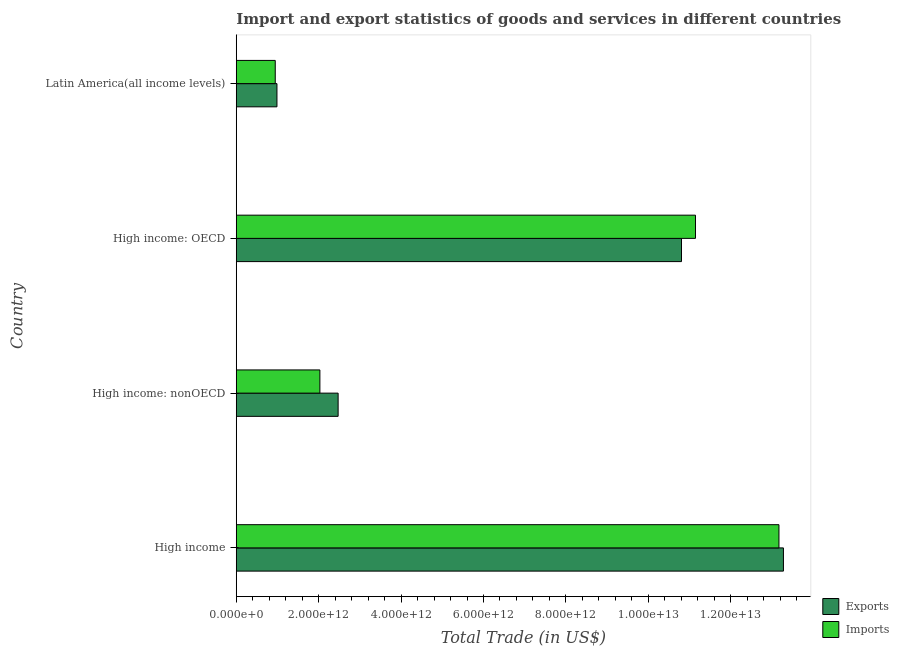How many groups of bars are there?
Provide a succinct answer. 4. How many bars are there on the 2nd tick from the top?
Offer a very short reply. 2. How many bars are there on the 4th tick from the bottom?
Provide a succinct answer. 2. What is the label of the 4th group of bars from the top?
Provide a short and direct response. High income. In how many cases, is the number of bars for a given country not equal to the number of legend labels?
Ensure brevity in your answer.  0. What is the imports of goods and services in Latin America(all income levels)?
Provide a short and direct response. 9.46e+11. Across all countries, what is the maximum imports of goods and services?
Give a very brief answer. 1.32e+13. Across all countries, what is the minimum imports of goods and services?
Offer a terse response. 9.46e+11. In which country was the export of goods and services maximum?
Provide a succinct answer. High income. In which country was the export of goods and services minimum?
Provide a short and direct response. Latin America(all income levels). What is the total export of goods and services in the graph?
Offer a very short reply. 2.75e+13. What is the difference between the imports of goods and services in High income: OECD and that in High income: nonOECD?
Ensure brevity in your answer.  9.12e+12. What is the difference between the imports of goods and services in High income: OECD and the export of goods and services in High income: nonOECD?
Your response must be concise. 8.67e+12. What is the average imports of goods and services per country?
Provide a succinct answer. 6.82e+12. What is the difference between the imports of goods and services and export of goods and services in High income: nonOECD?
Provide a succinct answer. -4.42e+11. What is the ratio of the imports of goods and services in High income: nonOECD to that in Latin America(all income levels)?
Keep it short and to the point. 2.15. Is the difference between the imports of goods and services in High income: OECD and High income: nonOECD greater than the difference between the export of goods and services in High income: OECD and High income: nonOECD?
Provide a succinct answer. Yes. What is the difference between the highest and the second highest imports of goods and services?
Make the answer very short. 2.03e+12. What is the difference between the highest and the lowest imports of goods and services?
Give a very brief answer. 1.22e+13. Is the sum of the export of goods and services in High income: nonOECD and Latin America(all income levels) greater than the maximum imports of goods and services across all countries?
Ensure brevity in your answer.  No. What does the 1st bar from the top in Latin America(all income levels) represents?
Make the answer very short. Imports. What does the 1st bar from the bottom in High income: OECD represents?
Make the answer very short. Exports. How many bars are there?
Offer a very short reply. 8. How many countries are there in the graph?
Your answer should be very brief. 4. What is the difference between two consecutive major ticks on the X-axis?
Give a very brief answer. 2.00e+12. Where does the legend appear in the graph?
Ensure brevity in your answer.  Bottom right. How are the legend labels stacked?
Your answer should be compact. Vertical. What is the title of the graph?
Keep it short and to the point. Import and export statistics of goods and services in different countries. What is the label or title of the X-axis?
Provide a short and direct response. Total Trade (in US$). What is the label or title of the Y-axis?
Give a very brief answer. Country. What is the Total Trade (in US$) of Exports in High income?
Ensure brevity in your answer.  1.33e+13. What is the Total Trade (in US$) of Imports in High income?
Make the answer very short. 1.32e+13. What is the Total Trade (in US$) of Exports in High income: nonOECD?
Ensure brevity in your answer.  2.47e+12. What is the Total Trade (in US$) of Imports in High income: nonOECD?
Ensure brevity in your answer.  2.03e+12. What is the Total Trade (in US$) in Exports in High income: OECD?
Provide a short and direct response. 1.08e+13. What is the Total Trade (in US$) of Imports in High income: OECD?
Provide a short and direct response. 1.11e+13. What is the Total Trade (in US$) of Exports in Latin America(all income levels)?
Provide a succinct answer. 9.88e+11. What is the Total Trade (in US$) in Imports in Latin America(all income levels)?
Provide a succinct answer. 9.46e+11. Across all countries, what is the maximum Total Trade (in US$) in Exports?
Your response must be concise. 1.33e+13. Across all countries, what is the maximum Total Trade (in US$) in Imports?
Offer a terse response. 1.32e+13. Across all countries, what is the minimum Total Trade (in US$) of Exports?
Ensure brevity in your answer.  9.88e+11. Across all countries, what is the minimum Total Trade (in US$) in Imports?
Your response must be concise. 9.46e+11. What is the total Total Trade (in US$) of Exports in the graph?
Ensure brevity in your answer.  2.75e+13. What is the total Total Trade (in US$) in Imports in the graph?
Your answer should be compact. 2.73e+13. What is the difference between the Total Trade (in US$) in Exports in High income and that in High income: nonOECD?
Ensure brevity in your answer.  1.08e+13. What is the difference between the Total Trade (in US$) of Imports in High income and that in High income: nonOECD?
Provide a succinct answer. 1.11e+13. What is the difference between the Total Trade (in US$) in Exports in High income and that in High income: OECD?
Your answer should be compact. 2.47e+12. What is the difference between the Total Trade (in US$) in Imports in High income and that in High income: OECD?
Ensure brevity in your answer.  2.03e+12. What is the difference between the Total Trade (in US$) in Exports in High income and that in Latin America(all income levels)?
Give a very brief answer. 1.23e+13. What is the difference between the Total Trade (in US$) in Imports in High income and that in Latin America(all income levels)?
Give a very brief answer. 1.22e+13. What is the difference between the Total Trade (in US$) of Exports in High income: nonOECD and that in High income: OECD?
Your answer should be very brief. -8.33e+12. What is the difference between the Total Trade (in US$) of Imports in High income: nonOECD and that in High income: OECD?
Offer a very short reply. -9.12e+12. What is the difference between the Total Trade (in US$) of Exports in High income: nonOECD and that in Latin America(all income levels)?
Provide a short and direct response. 1.48e+12. What is the difference between the Total Trade (in US$) of Imports in High income: nonOECD and that in Latin America(all income levels)?
Provide a succinct answer. 1.08e+12. What is the difference between the Total Trade (in US$) in Exports in High income: OECD and that in Latin America(all income levels)?
Give a very brief answer. 9.82e+12. What is the difference between the Total Trade (in US$) in Imports in High income: OECD and that in Latin America(all income levels)?
Give a very brief answer. 1.02e+13. What is the difference between the Total Trade (in US$) in Exports in High income and the Total Trade (in US$) in Imports in High income: nonOECD?
Ensure brevity in your answer.  1.12e+13. What is the difference between the Total Trade (in US$) of Exports in High income and the Total Trade (in US$) of Imports in High income: OECD?
Ensure brevity in your answer.  2.13e+12. What is the difference between the Total Trade (in US$) in Exports in High income and the Total Trade (in US$) in Imports in Latin America(all income levels)?
Keep it short and to the point. 1.23e+13. What is the difference between the Total Trade (in US$) in Exports in High income: nonOECD and the Total Trade (in US$) in Imports in High income: OECD?
Your answer should be compact. -8.67e+12. What is the difference between the Total Trade (in US$) in Exports in High income: nonOECD and the Total Trade (in US$) in Imports in Latin America(all income levels)?
Provide a short and direct response. 1.53e+12. What is the difference between the Total Trade (in US$) in Exports in High income: OECD and the Total Trade (in US$) in Imports in Latin America(all income levels)?
Your response must be concise. 9.86e+12. What is the average Total Trade (in US$) of Exports per country?
Your answer should be compact. 6.89e+12. What is the average Total Trade (in US$) in Imports per country?
Provide a short and direct response. 6.82e+12. What is the difference between the Total Trade (in US$) in Exports and Total Trade (in US$) in Imports in High income?
Your response must be concise. 1.09e+11. What is the difference between the Total Trade (in US$) of Exports and Total Trade (in US$) of Imports in High income: nonOECD?
Provide a succinct answer. 4.42e+11. What is the difference between the Total Trade (in US$) in Exports and Total Trade (in US$) in Imports in High income: OECD?
Provide a short and direct response. -3.39e+11. What is the difference between the Total Trade (in US$) in Exports and Total Trade (in US$) in Imports in Latin America(all income levels)?
Your answer should be compact. 4.12e+1. What is the ratio of the Total Trade (in US$) of Exports in High income to that in High income: nonOECD?
Provide a short and direct response. 5.37. What is the ratio of the Total Trade (in US$) of Imports in High income to that in High income: nonOECD?
Offer a very short reply. 6.49. What is the ratio of the Total Trade (in US$) in Exports in High income to that in High income: OECD?
Your answer should be compact. 1.23. What is the ratio of the Total Trade (in US$) in Imports in High income to that in High income: OECD?
Ensure brevity in your answer.  1.18. What is the ratio of the Total Trade (in US$) of Exports in High income to that in Latin America(all income levels)?
Your answer should be compact. 13.44. What is the ratio of the Total Trade (in US$) of Imports in High income to that in Latin America(all income levels)?
Your answer should be compact. 13.92. What is the ratio of the Total Trade (in US$) of Exports in High income: nonOECD to that in High income: OECD?
Ensure brevity in your answer.  0.23. What is the ratio of the Total Trade (in US$) of Imports in High income: nonOECD to that in High income: OECD?
Ensure brevity in your answer.  0.18. What is the ratio of the Total Trade (in US$) in Exports in High income: nonOECD to that in Latin America(all income levels)?
Ensure brevity in your answer.  2.5. What is the ratio of the Total Trade (in US$) of Imports in High income: nonOECD to that in Latin America(all income levels)?
Ensure brevity in your answer.  2.14. What is the ratio of the Total Trade (in US$) of Exports in High income: OECD to that in Latin America(all income levels)?
Your answer should be very brief. 10.94. What is the ratio of the Total Trade (in US$) of Imports in High income: OECD to that in Latin America(all income levels)?
Offer a very short reply. 11.78. What is the difference between the highest and the second highest Total Trade (in US$) in Exports?
Your answer should be compact. 2.47e+12. What is the difference between the highest and the second highest Total Trade (in US$) of Imports?
Your response must be concise. 2.03e+12. What is the difference between the highest and the lowest Total Trade (in US$) in Exports?
Make the answer very short. 1.23e+13. What is the difference between the highest and the lowest Total Trade (in US$) of Imports?
Keep it short and to the point. 1.22e+13. 